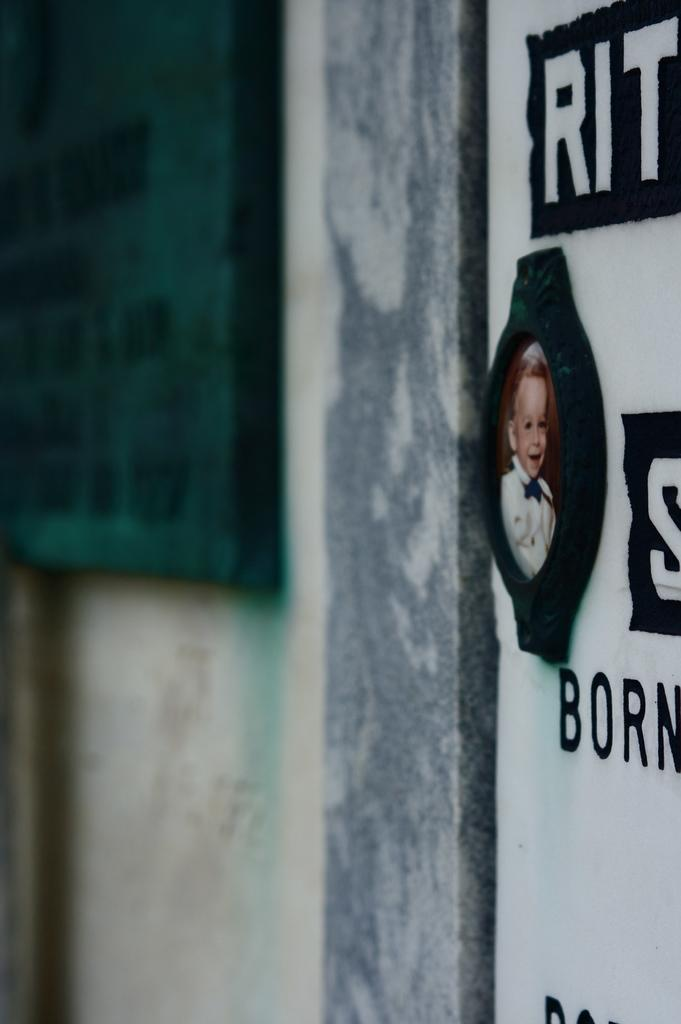What is present on the wall in the image? There is a picture frame on the wall. What else can be seen on the wall in the image? There is a poster on the right side of the image. Can you describe the poster in the image? The poster has text and an image on it. How many clocks are visible on the wall in the image? There are no clocks visible on the wall in the image. What type of paper is used to create the poster in the image? The image does not provide information about the type of paper used for the poster. 